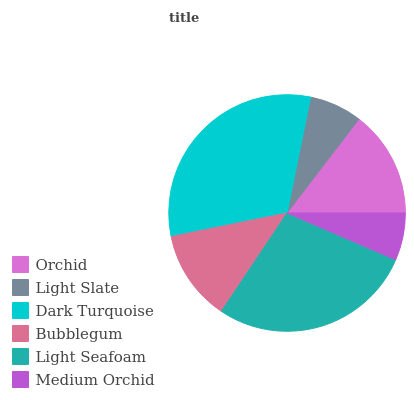Is Medium Orchid the minimum?
Answer yes or no. Yes. Is Dark Turquoise the maximum?
Answer yes or no. Yes. Is Light Slate the minimum?
Answer yes or no. No. Is Light Slate the maximum?
Answer yes or no. No. Is Orchid greater than Light Slate?
Answer yes or no. Yes. Is Light Slate less than Orchid?
Answer yes or no. Yes. Is Light Slate greater than Orchid?
Answer yes or no. No. Is Orchid less than Light Slate?
Answer yes or no. No. Is Orchid the high median?
Answer yes or no. Yes. Is Bubblegum the low median?
Answer yes or no. Yes. Is Light Slate the high median?
Answer yes or no. No. Is Orchid the low median?
Answer yes or no. No. 